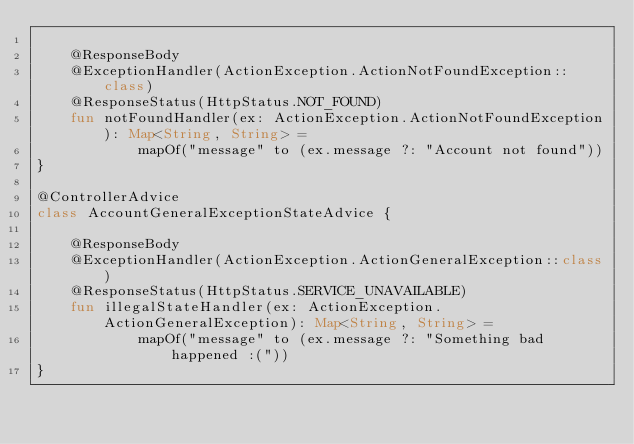Convert code to text. <code><loc_0><loc_0><loc_500><loc_500><_Kotlin_>
    @ResponseBody
    @ExceptionHandler(ActionException.ActionNotFoundException::class)
    @ResponseStatus(HttpStatus.NOT_FOUND)
    fun notFoundHandler(ex: ActionException.ActionNotFoundException): Map<String, String> =
            mapOf("message" to (ex.message ?: "Account not found"))
}

@ControllerAdvice
class AccountGeneralExceptionStateAdvice {

    @ResponseBody
    @ExceptionHandler(ActionException.ActionGeneralException::class)
    @ResponseStatus(HttpStatus.SERVICE_UNAVAILABLE)
    fun illegalStateHandler(ex: ActionException.ActionGeneralException): Map<String, String> =
            mapOf("message" to (ex.message ?: "Something bad happened :("))
}
</code> 